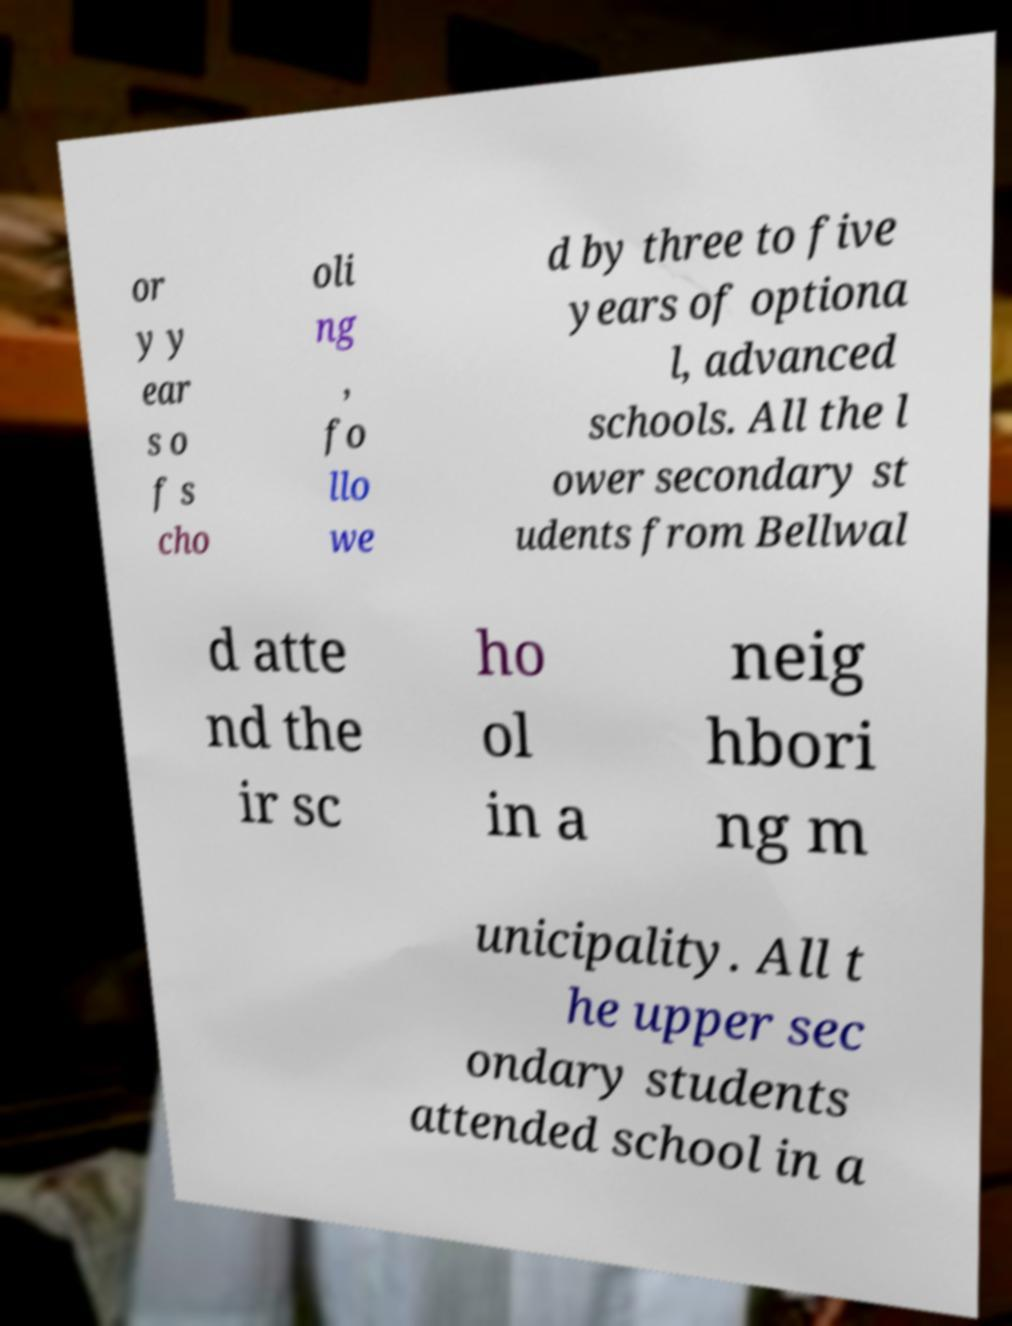Can you read and provide the text displayed in the image?This photo seems to have some interesting text. Can you extract and type it out for me? or y y ear s o f s cho oli ng , fo llo we d by three to five years of optiona l, advanced schools. All the l ower secondary st udents from Bellwal d atte nd the ir sc ho ol in a neig hbori ng m unicipality. All t he upper sec ondary students attended school in a 